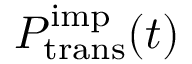Convert formula to latex. <formula><loc_0><loc_0><loc_500><loc_500>P _ { t r a n s } ^ { i m p } ( t )</formula> 